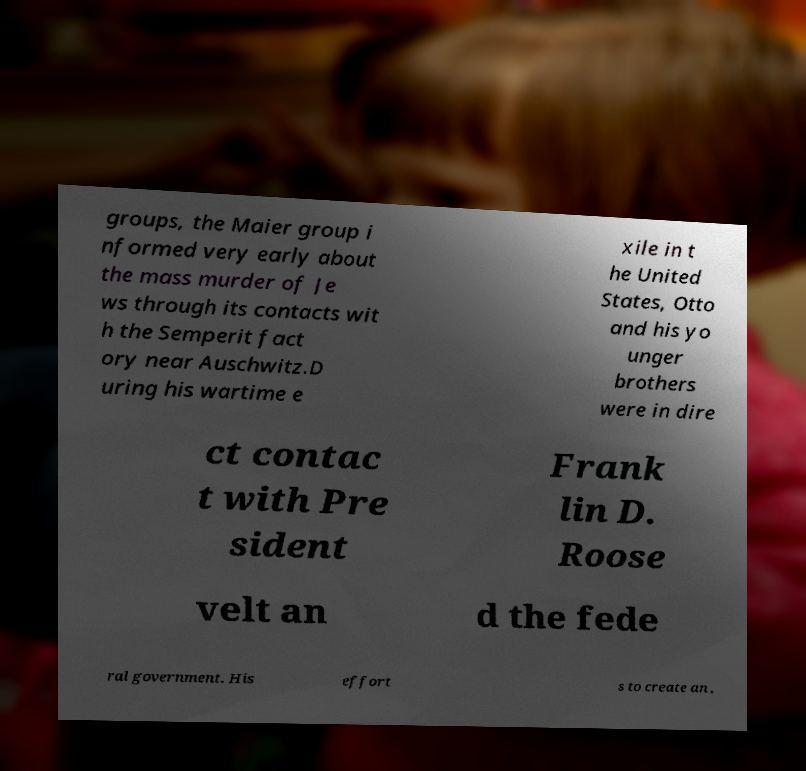Please identify and transcribe the text found in this image. groups, the Maier group i nformed very early about the mass murder of Je ws through its contacts wit h the Semperit fact ory near Auschwitz.D uring his wartime e xile in t he United States, Otto and his yo unger brothers were in dire ct contac t with Pre sident Frank lin D. Roose velt an d the fede ral government. His effort s to create an , 